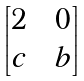<formula> <loc_0><loc_0><loc_500><loc_500>\begin{bmatrix} 2 \, & \, 0 \\ c \, & \, b \end{bmatrix}</formula> 